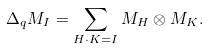<formula> <loc_0><loc_0><loc_500><loc_500>\Delta _ { q } M _ { I } = \sum _ { H \cdot K = I } M _ { H } \otimes M _ { K } .</formula> 